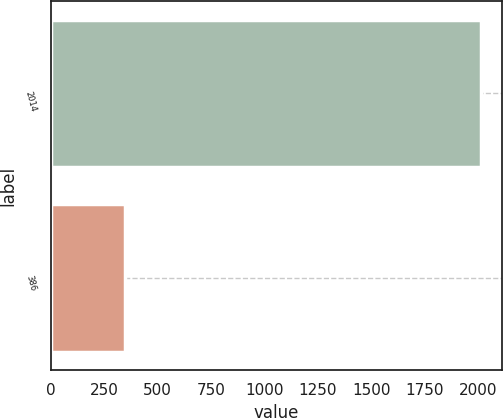Convert chart to OTSL. <chart><loc_0><loc_0><loc_500><loc_500><bar_chart><fcel>2014<fcel>386<nl><fcel>2013<fcel>348<nl></chart> 